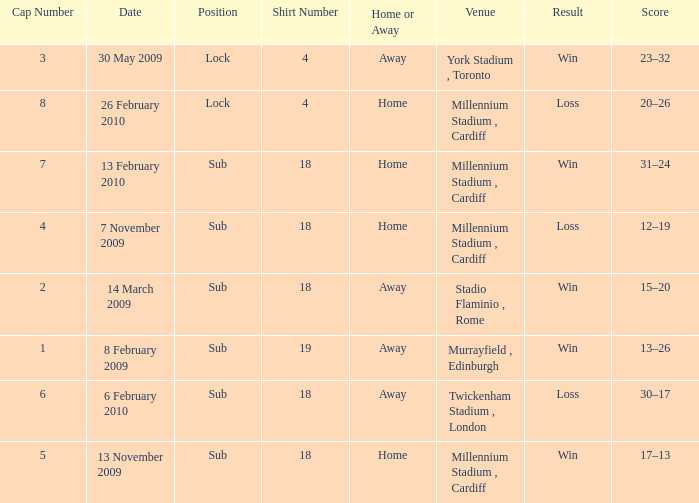Can you tell me the lowest Cap Number that has the Date of 8 february 2009, and the Shirt Number larger than 19? None. 